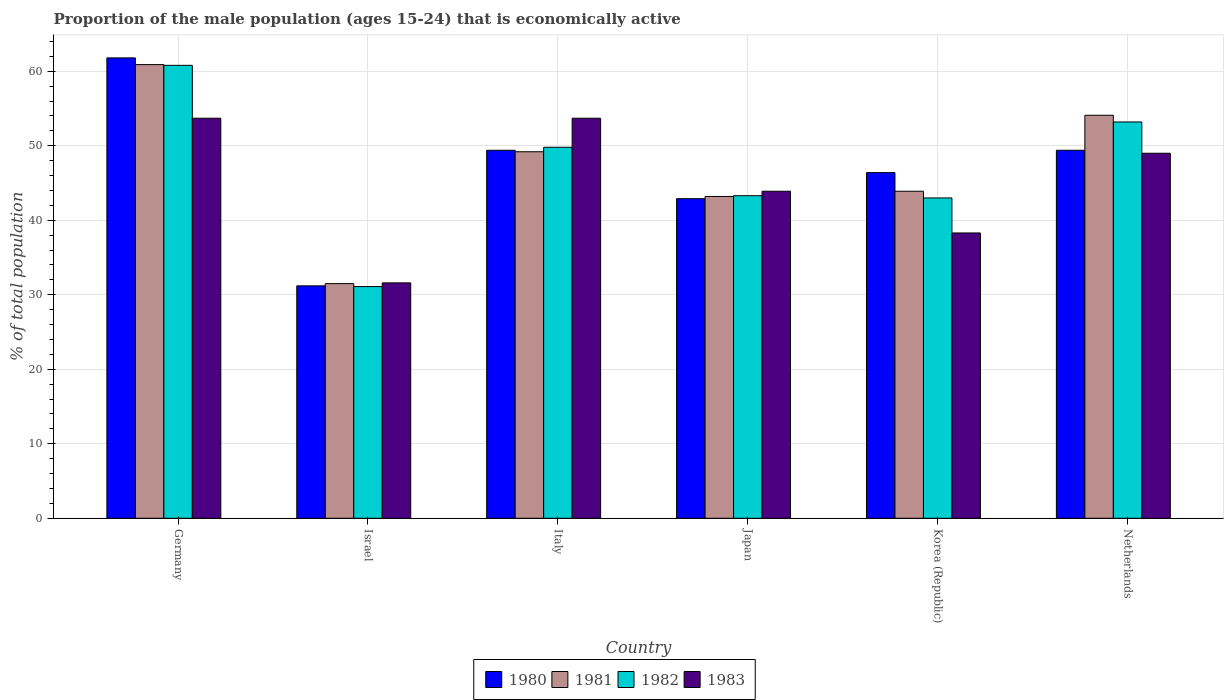How many different coloured bars are there?
Your answer should be compact. 4. How many groups of bars are there?
Keep it short and to the point. 6. Are the number of bars per tick equal to the number of legend labels?
Keep it short and to the point. Yes. Are the number of bars on each tick of the X-axis equal?
Keep it short and to the point. Yes. What is the label of the 5th group of bars from the left?
Offer a terse response. Korea (Republic). What is the proportion of the male population that is economically active in 1980 in Italy?
Give a very brief answer. 49.4. Across all countries, what is the maximum proportion of the male population that is economically active in 1981?
Your answer should be compact. 60.9. Across all countries, what is the minimum proportion of the male population that is economically active in 1981?
Your response must be concise. 31.5. What is the total proportion of the male population that is economically active in 1982 in the graph?
Offer a very short reply. 281.2. What is the difference between the proportion of the male population that is economically active in 1980 in Israel and that in Italy?
Make the answer very short. -18.2. What is the difference between the proportion of the male population that is economically active in 1983 in Netherlands and the proportion of the male population that is economically active in 1980 in Italy?
Offer a very short reply. -0.4. What is the average proportion of the male population that is economically active in 1980 per country?
Your answer should be very brief. 46.85. What is the difference between the proportion of the male population that is economically active of/in 1982 and proportion of the male population that is economically active of/in 1983 in Israel?
Offer a very short reply. -0.5. What is the ratio of the proportion of the male population that is economically active in 1981 in Korea (Republic) to that in Netherlands?
Provide a short and direct response. 0.81. Is the proportion of the male population that is economically active in 1981 in Germany less than that in Israel?
Your answer should be compact. No. What is the difference between the highest and the lowest proportion of the male population that is economically active in 1982?
Give a very brief answer. 29.7. In how many countries, is the proportion of the male population that is economically active in 1983 greater than the average proportion of the male population that is economically active in 1983 taken over all countries?
Keep it short and to the point. 3. What does the 4th bar from the left in Italy represents?
Keep it short and to the point. 1983. Is it the case that in every country, the sum of the proportion of the male population that is economically active in 1981 and proportion of the male population that is economically active in 1983 is greater than the proportion of the male population that is economically active in 1982?
Give a very brief answer. Yes. How many bars are there?
Your response must be concise. 24. Are all the bars in the graph horizontal?
Keep it short and to the point. No. How many countries are there in the graph?
Give a very brief answer. 6. How many legend labels are there?
Offer a very short reply. 4. What is the title of the graph?
Offer a very short reply. Proportion of the male population (ages 15-24) that is economically active. What is the label or title of the Y-axis?
Ensure brevity in your answer.  % of total population. What is the % of total population in 1980 in Germany?
Make the answer very short. 61.8. What is the % of total population in 1981 in Germany?
Offer a terse response. 60.9. What is the % of total population in 1982 in Germany?
Offer a terse response. 60.8. What is the % of total population in 1983 in Germany?
Give a very brief answer. 53.7. What is the % of total population in 1980 in Israel?
Provide a succinct answer. 31.2. What is the % of total population in 1981 in Israel?
Your answer should be compact. 31.5. What is the % of total population of 1982 in Israel?
Your response must be concise. 31.1. What is the % of total population in 1983 in Israel?
Give a very brief answer. 31.6. What is the % of total population of 1980 in Italy?
Provide a succinct answer. 49.4. What is the % of total population in 1981 in Italy?
Your answer should be compact. 49.2. What is the % of total population in 1982 in Italy?
Offer a very short reply. 49.8. What is the % of total population of 1983 in Italy?
Your answer should be very brief. 53.7. What is the % of total population of 1980 in Japan?
Offer a terse response. 42.9. What is the % of total population in 1981 in Japan?
Provide a short and direct response. 43.2. What is the % of total population of 1982 in Japan?
Offer a very short reply. 43.3. What is the % of total population in 1983 in Japan?
Provide a short and direct response. 43.9. What is the % of total population of 1980 in Korea (Republic)?
Keep it short and to the point. 46.4. What is the % of total population in 1981 in Korea (Republic)?
Offer a terse response. 43.9. What is the % of total population in 1983 in Korea (Republic)?
Offer a terse response. 38.3. What is the % of total population of 1980 in Netherlands?
Your answer should be compact. 49.4. What is the % of total population of 1981 in Netherlands?
Provide a short and direct response. 54.1. What is the % of total population in 1982 in Netherlands?
Provide a succinct answer. 53.2. What is the % of total population of 1983 in Netherlands?
Keep it short and to the point. 49. Across all countries, what is the maximum % of total population in 1980?
Provide a short and direct response. 61.8. Across all countries, what is the maximum % of total population of 1981?
Provide a short and direct response. 60.9. Across all countries, what is the maximum % of total population of 1982?
Your answer should be compact. 60.8. Across all countries, what is the maximum % of total population of 1983?
Your response must be concise. 53.7. Across all countries, what is the minimum % of total population in 1980?
Provide a short and direct response. 31.2. Across all countries, what is the minimum % of total population of 1981?
Offer a terse response. 31.5. Across all countries, what is the minimum % of total population in 1982?
Make the answer very short. 31.1. Across all countries, what is the minimum % of total population in 1983?
Your answer should be very brief. 31.6. What is the total % of total population in 1980 in the graph?
Offer a terse response. 281.1. What is the total % of total population in 1981 in the graph?
Your response must be concise. 282.8. What is the total % of total population of 1982 in the graph?
Provide a succinct answer. 281.2. What is the total % of total population of 1983 in the graph?
Make the answer very short. 270.2. What is the difference between the % of total population of 1980 in Germany and that in Israel?
Your answer should be very brief. 30.6. What is the difference between the % of total population in 1981 in Germany and that in Israel?
Provide a succinct answer. 29.4. What is the difference between the % of total population in 1982 in Germany and that in Israel?
Give a very brief answer. 29.7. What is the difference between the % of total population in 1983 in Germany and that in Israel?
Your answer should be compact. 22.1. What is the difference between the % of total population in 1980 in Germany and that in Italy?
Offer a terse response. 12.4. What is the difference between the % of total population in 1983 in Germany and that in Italy?
Your response must be concise. 0. What is the difference between the % of total population in 1980 in Germany and that in Japan?
Ensure brevity in your answer.  18.9. What is the difference between the % of total population of 1981 in Germany and that in Japan?
Offer a very short reply. 17.7. What is the difference between the % of total population of 1983 in Germany and that in Japan?
Provide a short and direct response. 9.8. What is the difference between the % of total population in 1980 in Germany and that in Korea (Republic)?
Provide a succinct answer. 15.4. What is the difference between the % of total population of 1981 in Germany and that in Korea (Republic)?
Provide a short and direct response. 17. What is the difference between the % of total population of 1982 in Germany and that in Korea (Republic)?
Provide a succinct answer. 17.8. What is the difference between the % of total population of 1983 in Germany and that in Netherlands?
Ensure brevity in your answer.  4.7. What is the difference between the % of total population in 1980 in Israel and that in Italy?
Keep it short and to the point. -18.2. What is the difference between the % of total population in 1981 in Israel and that in Italy?
Offer a terse response. -17.7. What is the difference between the % of total population in 1982 in Israel and that in Italy?
Make the answer very short. -18.7. What is the difference between the % of total population of 1983 in Israel and that in Italy?
Your answer should be very brief. -22.1. What is the difference between the % of total population in 1980 in Israel and that in Japan?
Offer a very short reply. -11.7. What is the difference between the % of total population of 1981 in Israel and that in Japan?
Your answer should be compact. -11.7. What is the difference between the % of total population of 1982 in Israel and that in Japan?
Ensure brevity in your answer.  -12.2. What is the difference between the % of total population in 1980 in Israel and that in Korea (Republic)?
Give a very brief answer. -15.2. What is the difference between the % of total population in 1981 in Israel and that in Korea (Republic)?
Ensure brevity in your answer.  -12.4. What is the difference between the % of total population in 1982 in Israel and that in Korea (Republic)?
Ensure brevity in your answer.  -11.9. What is the difference between the % of total population in 1983 in Israel and that in Korea (Republic)?
Your response must be concise. -6.7. What is the difference between the % of total population in 1980 in Israel and that in Netherlands?
Your response must be concise. -18.2. What is the difference between the % of total population in 1981 in Israel and that in Netherlands?
Provide a short and direct response. -22.6. What is the difference between the % of total population in 1982 in Israel and that in Netherlands?
Give a very brief answer. -22.1. What is the difference between the % of total population of 1983 in Israel and that in Netherlands?
Offer a very short reply. -17.4. What is the difference between the % of total population of 1980 in Italy and that in Japan?
Offer a very short reply. 6.5. What is the difference between the % of total population of 1981 in Italy and that in Japan?
Offer a very short reply. 6. What is the difference between the % of total population in 1980 in Italy and that in Korea (Republic)?
Your answer should be compact. 3. What is the difference between the % of total population in 1981 in Italy and that in Korea (Republic)?
Offer a very short reply. 5.3. What is the difference between the % of total population in 1980 in Italy and that in Netherlands?
Ensure brevity in your answer.  0. What is the difference between the % of total population in 1982 in Japan and that in Korea (Republic)?
Give a very brief answer. 0.3. What is the difference between the % of total population of 1982 in Japan and that in Netherlands?
Provide a short and direct response. -9.9. What is the difference between the % of total population of 1983 in Japan and that in Netherlands?
Offer a terse response. -5.1. What is the difference between the % of total population of 1980 in Korea (Republic) and that in Netherlands?
Offer a terse response. -3. What is the difference between the % of total population of 1981 in Korea (Republic) and that in Netherlands?
Ensure brevity in your answer.  -10.2. What is the difference between the % of total population of 1983 in Korea (Republic) and that in Netherlands?
Your answer should be compact. -10.7. What is the difference between the % of total population of 1980 in Germany and the % of total population of 1981 in Israel?
Offer a terse response. 30.3. What is the difference between the % of total population of 1980 in Germany and the % of total population of 1982 in Israel?
Keep it short and to the point. 30.7. What is the difference between the % of total population of 1980 in Germany and the % of total population of 1983 in Israel?
Ensure brevity in your answer.  30.2. What is the difference between the % of total population of 1981 in Germany and the % of total population of 1982 in Israel?
Ensure brevity in your answer.  29.8. What is the difference between the % of total population of 1981 in Germany and the % of total population of 1983 in Israel?
Provide a short and direct response. 29.3. What is the difference between the % of total population of 1982 in Germany and the % of total population of 1983 in Israel?
Your response must be concise. 29.2. What is the difference between the % of total population of 1980 in Germany and the % of total population of 1981 in Italy?
Offer a terse response. 12.6. What is the difference between the % of total population in 1980 in Germany and the % of total population in 1981 in Japan?
Your answer should be compact. 18.6. What is the difference between the % of total population of 1980 in Germany and the % of total population of 1982 in Japan?
Your answer should be compact. 18.5. What is the difference between the % of total population of 1980 in Germany and the % of total population of 1983 in Japan?
Provide a short and direct response. 17.9. What is the difference between the % of total population of 1981 in Germany and the % of total population of 1982 in Japan?
Your answer should be very brief. 17.6. What is the difference between the % of total population of 1981 in Germany and the % of total population of 1983 in Japan?
Offer a terse response. 17. What is the difference between the % of total population of 1980 in Germany and the % of total population of 1982 in Korea (Republic)?
Your response must be concise. 18.8. What is the difference between the % of total population in 1980 in Germany and the % of total population in 1983 in Korea (Republic)?
Give a very brief answer. 23.5. What is the difference between the % of total population of 1981 in Germany and the % of total population of 1983 in Korea (Republic)?
Offer a terse response. 22.6. What is the difference between the % of total population in 1982 in Germany and the % of total population in 1983 in Korea (Republic)?
Your answer should be compact. 22.5. What is the difference between the % of total population in 1980 in Germany and the % of total population in 1983 in Netherlands?
Ensure brevity in your answer.  12.8. What is the difference between the % of total population of 1981 in Germany and the % of total population of 1983 in Netherlands?
Provide a short and direct response. 11.9. What is the difference between the % of total population of 1980 in Israel and the % of total population of 1981 in Italy?
Make the answer very short. -18. What is the difference between the % of total population in 1980 in Israel and the % of total population in 1982 in Italy?
Give a very brief answer. -18.6. What is the difference between the % of total population of 1980 in Israel and the % of total population of 1983 in Italy?
Provide a short and direct response. -22.5. What is the difference between the % of total population of 1981 in Israel and the % of total population of 1982 in Italy?
Provide a succinct answer. -18.3. What is the difference between the % of total population in 1981 in Israel and the % of total population in 1983 in Italy?
Ensure brevity in your answer.  -22.2. What is the difference between the % of total population in 1982 in Israel and the % of total population in 1983 in Italy?
Provide a short and direct response. -22.6. What is the difference between the % of total population of 1980 in Israel and the % of total population of 1981 in Japan?
Your answer should be compact. -12. What is the difference between the % of total population in 1982 in Israel and the % of total population in 1983 in Japan?
Give a very brief answer. -12.8. What is the difference between the % of total population of 1980 in Israel and the % of total population of 1982 in Korea (Republic)?
Give a very brief answer. -11.8. What is the difference between the % of total population of 1980 in Israel and the % of total population of 1983 in Korea (Republic)?
Ensure brevity in your answer.  -7.1. What is the difference between the % of total population in 1980 in Israel and the % of total population in 1981 in Netherlands?
Your response must be concise. -22.9. What is the difference between the % of total population in 1980 in Israel and the % of total population in 1982 in Netherlands?
Offer a very short reply. -22. What is the difference between the % of total population in 1980 in Israel and the % of total population in 1983 in Netherlands?
Make the answer very short. -17.8. What is the difference between the % of total population of 1981 in Israel and the % of total population of 1982 in Netherlands?
Offer a terse response. -21.7. What is the difference between the % of total population in 1981 in Israel and the % of total population in 1983 in Netherlands?
Provide a succinct answer. -17.5. What is the difference between the % of total population in 1982 in Israel and the % of total population in 1983 in Netherlands?
Your response must be concise. -17.9. What is the difference between the % of total population of 1980 in Italy and the % of total population of 1982 in Japan?
Ensure brevity in your answer.  6.1. What is the difference between the % of total population in 1981 in Italy and the % of total population in 1982 in Japan?
Your answer should be compact. 5.9. What is the difference between the % of total population in 1981 in Italy and the % of total population in 1983 in Japan?
Ensure brevity in your answer.  5.3. What is the difference between the % of total population in 1982 in Italy and the % of total population in 1983 in Japan?
Offer a terse response. 5.9. What is the difference between the % of total population of 1980 in Italy and the % of total population of 1983 in Korea (Republic)?
Your answer should be very brief. 11.1. What is the difference between the % of total population of 1981 in Italy and the % of total population of 1982 in Korea (Republic)?
Keep it short and to the point. 6.2. What is the difference between the % of total population in 1981 in Italy and the % of total population in 1983 in Korea (Republic)?
Ensure brevity in your answer.  10.9. What is the difference between the % of total population in 1982 in Italy and the % of total population in 1983 in Korea (Republic)?
Your response must be concise. 11.5. What is the difference between the % of total population in 1980 in Italy and the % of total population in 1981 in Netherlands?
Your answer should be compact. -4.7. What is the difference between the % of total population in 1980 in Italy and the % of total population in 1982 in Netherlands?
Ensure brevity in your answer.  -3.8. What is the difference between the % of total population of 1981 in Italy and the % of total population of 1982 in Netherlands?
Give a very brief answer. -4. What is the difference between the % of total population in 1981 in Italy and the % of total population in 1983 in Netherlands?
Keep it short and to the point. 0.2. What is the difference between the % of total population of 1982 in Italy and the % of total population of 1983 in Netherlands?
Your answer should be compact. 0.8. What is the difference between the % of total population of 1980 in Japan and the % of total population of 1981 in Korea (Republic)?
Make the answer very short. -1. What is the difference between the % of total population in 1981 in Japan and the % of total population in 1983 in Korea (Republic)?
Keep it short and to the point. 4.9. What is the difference between the % of total population of 1980 in Japan and the % of total population of 1983 in Netherlands?
Ensure brevity in your answer.  -6.1. What is the difference between the % of total population of 1980 in Korea (Republic) and the % of total population of 1981 in Netherlands?
Offer a terse response. -7.7. What is the difference between the % of total population of 1982 in Korea (Republic) and the % of total population of 1983 in Netherlands?
Provide a succinct answer. -6. What is the average % of total population in 1980 per country?
Your answer should be compact. 46.85. What is the average % of total population of 1981 per country?
Keep it short and to the point. 47.13. What is the average % of total population of 1982 per country?
Ensure brevity in your answer.  46.87. What is the average % of total population in 1983 per country?
Keep it short and to the point. 45.03. What is the difference between the % of total population in 1980 and % of total population in 1981 in Germany?
Your response must be concise. 0.9. What is the difference between the % of total population of 1980 and % of total population of 1983 in Germany?
Offer a very short reply. 8.1. What is the difference between the % of total population in 1981 and % of total population in 1982 in Germany?
Make the answer very short. 0.1. What is the difference between the % of total population of 1980 and % of total population of 1981 in Israel?
Keep it short and to the point. -0.3. What is the difference between the % of total population in 1981 and % of total population in 1982 in Israel?
Provide a short and direct response. 0.4. What is the difference between the % of total population of 1980 and % of total population of 1981 in Italy?
Your answer should be compact. 0.2. What is the difference between the % of total population of 1980 and % of total population of 1982 in Italy?
Your answer should be compact. -0.4. What is the difference between the % of total population in 1980 and % of total population in 1983 in Italy?
Ensure brevity in your answer.  -4.3. What is the difference between the % of total population in 1982 and % of total population in 1983 in Italy?
Your response must be concise. -3.9. What is the difference between the % of total population of 1980 and % of total population of 1981 in Japan?
Your response must be concise. -0.3. What is the difference between the % of total population in 1980 and % of total population in 1982 in Japan?
Offer a terse response. -0.4. What is the difference between the % of total population in 1981 and % of total population in 1983 in Japan?
Your response must be concise. -0.7. What is the difference between the % of total population in 1980 and % of total population in 1981 in Korea (Republic)?
Keep it short and to the point. 2.5. What is the difference between the % of total population in 1980 and % of total population in 1982 in Korea (Republic)?
Provide a succinct answer. 3.4. What is the difference between the % of total population of 1980 and % of total population of 1983 in Korea (Republic)?
Make the answer very short. 8.1. What is the difference between the % of total population of 1982 and % of total population of 1983 in Korea (Republic)?
Provide a succinct answer. 4.7. What is the difference between the % of total population in 1980 and % of total population in 1983 in Netherlands?
Make the answer very short. 0.4. What is the difference between the % of total population in 1981 and % of total population in 1983 in Netherlands?
Keep it short and to the point. 5.1. What is the difference between the % of total population in 1982 and % of total population in 1983 in Netherlands?
Keep it short and to the point. 4.2. What is the ratio of the % of total population in 1980 in Germany to that in Israel?
Ensure brevity in your answer.  1.98. What is the ratio of the % of total population in 1981 in Germany to that in Israel?
Make the answer very short. 1.93. What is the ratio of the % of total population in 1982 in Germany to that in Israel?
Offer a very short reply. 1.96. What is the ratio of the % of total population in 1983 in Germany to that in Israel?
Your response must be concise. 1.7. What is the ratio of the % of total population of 1980 in Germany to that in Italy?
Provide a short and direct response. 1.25. What is the ratio of the % of total population of 1981 in Germany to that in Italy?
Ensure brevity in your answer.  1.24. What is the ratio of the % of total population in 1982 in Germany to that in Italy?
Provide a short and direct response. 1.22. What is the ratio of the % of total population of 1983 in Germany to that in Italy?
Provide a succinct answer. 1. What is the ratio of the % of total population in 1980 in Germany to that in Japan?
Keep it short and to the point. 1.44. What is the ratio of the % of total population in 1981 in Germany to that in Japan?
Your answer should be compact. 1.41. What is the ratio of the % of total population of 1982 in Germany to that in Japan?
Ensure brevity in your answer.  1.4. What is the ratio of the % of total population in 1983 in Germany to that in Japan?
Provide a short and direct response. 1.22. What is the ratio of the % of total population of 1980 in Germany to that in Korea (Republic)?
Provide a short and direct response. 1.33. What is the ratio of the % of total population of 1981 in Germany to that in Korea (Republic)?
Provide a succinct answer. 1.39. What is the ratio of the % of total population of 1982 in Germany to that in Korea (Republic)?
Your answer should be compact. 1.41. What is the ratio of the % of total population in 1983 in Germany to that in Korea (Republic)?
Provide a short and direct response. 1.4. What is the ratio of the % of total population of 1980 in Germany to that in Netherlands?
Provide a short and direct response. 1.25. What is the ratio of the % of total population of 1981 in Germany to that in Netherlands?
Keep it short and to the point. 1.13. What is the ratio of the % of total population in 1982 in Germany to that in Netherlands?
Give a very brief answer. 1.14. What is the ratio of the % of total population of 1983 in Germany to that in Netherlands?
Keep it short and to the point. 1.1. What is the ratio of the % of total population in 1980 in Israel to that in Italy?
Your answer should be very brief. 0.63. What is the ratio of the % of total population in 1981 in Israel to that in Italy?
Provide a short and direct response. 0.64. What is the ratio of the % of total population of 1982 in Israel to that in Italy?
Your response must be concise. 0.62. What is the ratio of the % of total population of 1983 in Israel to that in Italy?
Keep it short and to the point. 0.59. What is the ratio of the % of total population in 1980 in Israel to that in Japan?
Offer a terse response. 0.73. What is the ratio of the % of total population in 1981 in Israel to that in Japan?
Your response must be concise. 0.73. What is the ratio of the % of total population in 1982 in Israel to that in Japan?
Your answer should be very brief. 0.72. What is the ratio of the % of total population in 1983 in Israel to that in Japan?
Ensure brevity in your answer.  0.72. What is the ratio of the % of total population in 1980 in Israel to that in Korea (Republic)?
Offer a very short reply. 0.67. What is the ratio of the % of total population of 1981 in Israel to that in Korea (Republic)?
Your answer should be compact. 0.72. What is the ratio of the % of total population in 1982 in Israel to that in Korea (Republic)?
Your response must be concise. 0.72. What is the ratio of the % of total population of 1983 in Israel to that in Korea (Republic)?
Make the answer very short. 0.83. What is the ratio of the % of total population in 1980 in Israel to that in Netherlands?
Make the answer very short. 0.63. What is the ratio of the % of total population in 1981 in Israel to that in Netherlands?
Your answer should be very brief. 0.58. What is the ratio of the % of total population of 1982 in Israel to that in Netherlands?
Make the answer very short. 0.58. What is the ratio of the % of total population of 1983 in Israel to that in Netherlands?
Make the answer very short. 0.64. What is the ratio of the % of total population of 1980 in Italy to that in Japan?
Provide a succinct answer. 1.15. What is the ratio of the % of total population in 1981 in Italy to that in Japan?
Give a very brief answer. 1.14. What is the ratio of the % of total population in 1982 in Italy to that in Japan?
Offer a very short reply. 1.15. What is the ratio of the % of total population of 1983 in Italy to that in Japan?
Provide a short and direct response. 1.22. What is the ratio of the % of total population in 1980 in Italy to that in Korea (Republic)?
Make the answer very short. 1.06. What is the ratio of the % of total population of 1981 in Italy to that in Korea (Republic)?
Provide a succinct answer. 1.12. What is the ratio of the % of total population in 1982 in Italy to that in Korea (Republic)?
Offer a terse response. 1.16. What is the ratio of the % of total population in 1983 in Italy to that in Korea (Republic)?
Ensure brevity in your answer.  1.4. What is the ratio of the % of total population of 1980 in Italy to that in Netherlands?
Ensure brevity in your answer.  1. What is the ratio of the % of total population in 1981 in Italy to that in Netherlands?
Keep it short and to the point. 0.91. What is the ratio of the % of total population of 1982 in Italy to that in Netherlands?
Ensure brevity in your answer.  0.94. What is the ratio of the % of total population of 1983 in Italy to that in Netherlands?
Make the answer very short. 1.1. What is the ratio of the % of total population of 1980 in Japan to that in Korea (Republic)?
Your answer should be very brief. 0.92. What is the ratio of the % of total population in 1981 in Japan to that in Korea (Republic)?
Your response must be concise. 0.98. What is the ratio of the % of total population of 1983 in Japan to that in Korea (Republic)?
Your answer should be compact. 1.15. What is the ratio of the % of total population in 1980 in Japan to that in Netherlands?
Provide a succinct answer. 0.87. What is the ratio of the % of total population in 1981 in Japan to that in Netherlands?
Ensure brevity in your answer.  0.8. What is the ratio of the % of total population of 1982 in Japan to that in Netherlands?
Provide a succinct answer. 0.81. What is the ratio of the % of total population of 1983 in Japan to that in Netherlands?
Provide a succinct answer. 0.9. What is the ratio of the % of total population in 1980 in Korea (Republic) to that in Netherlands?
Provide a short and direct response. 0.94. What is the ratio of the % of total population in 1981 in Korea (Republic) to that in Netherlands?
Give a very brief answer. 0.81. What is the ratio of the % of total population of 1982 in Korea (Republic) to that in Netherlands?
Ensure brevity in your answer.  0.81. What is the ratio of the % of total population of 1983 in Korea (Republic) to that in Netherlands?
Provide a succinct answer. 0.78. What is the difference between the highest and the second highest % of total population in 1981?
Give a very brief answer. 6.8. What is the difference between the highest and the second highest % of total population of 1983?
Your response must be concise. 0. What is the difference between the highest and the lowest % of total population in 1980?
Your answer should be compact. 30.6. What is the difference between the highest and the lowest % of total population in 1981?
Your response must be concise. 29.4. What is the difference between the highest and the lowest % of total population in 1982?
Make the answer very short. 29.7. What is the difference between the highest and the lowest % of total population in 1983?
Keep it short and to the point. 22.1. 